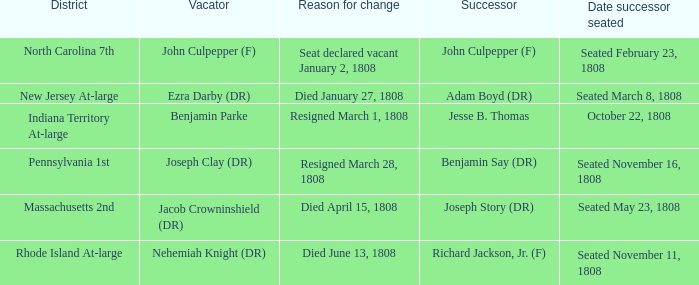Would you mind parsing the complete table? {'header': ['District', 'Vacator', 'Reason for change', 'Successor', 'Date successor seated'], 'rows': [['North Carolina 7th', 'John Culpepper (F)', 'Seat declared vacant January 2, 1808', 'John Culpepper (F)', 'Seated February 23, 1808'], ['New Jersey At-large', 'Ezra Darby (DR)', 'Died January 27, 1808', 'Adam Boyd (DR)', 'Seated March 8, 1808'], ['Indiana Territory At-large', 'Benjamin Parke', 'Resigned March 1, 1808', 'Jesse B. Thomas', 'October 22, 1808'], ['Pennsylvania 1st', 'Joseph Clay (DR)', 'Resigned March 28, 1808', 'Benjamin Say (DR)', 'Seated November 16, 1808'], ['Massachusetts 2nd', 'Jacob Crowninshield (DR)', 'Died April 15, 1808', 'Joseph Story (DR)', 'Seated May 23, 1808'], ['Rhode Island At-large', 'Nehemiah Knight (DR)', 'Died June 13, 1808', 'Richard Jackson, Jr. (F)', 'Seated November 11, 1808']]} Who is the successor when the reason for change is seat declared vacant January 2, 1808 John Culpepper (F). 